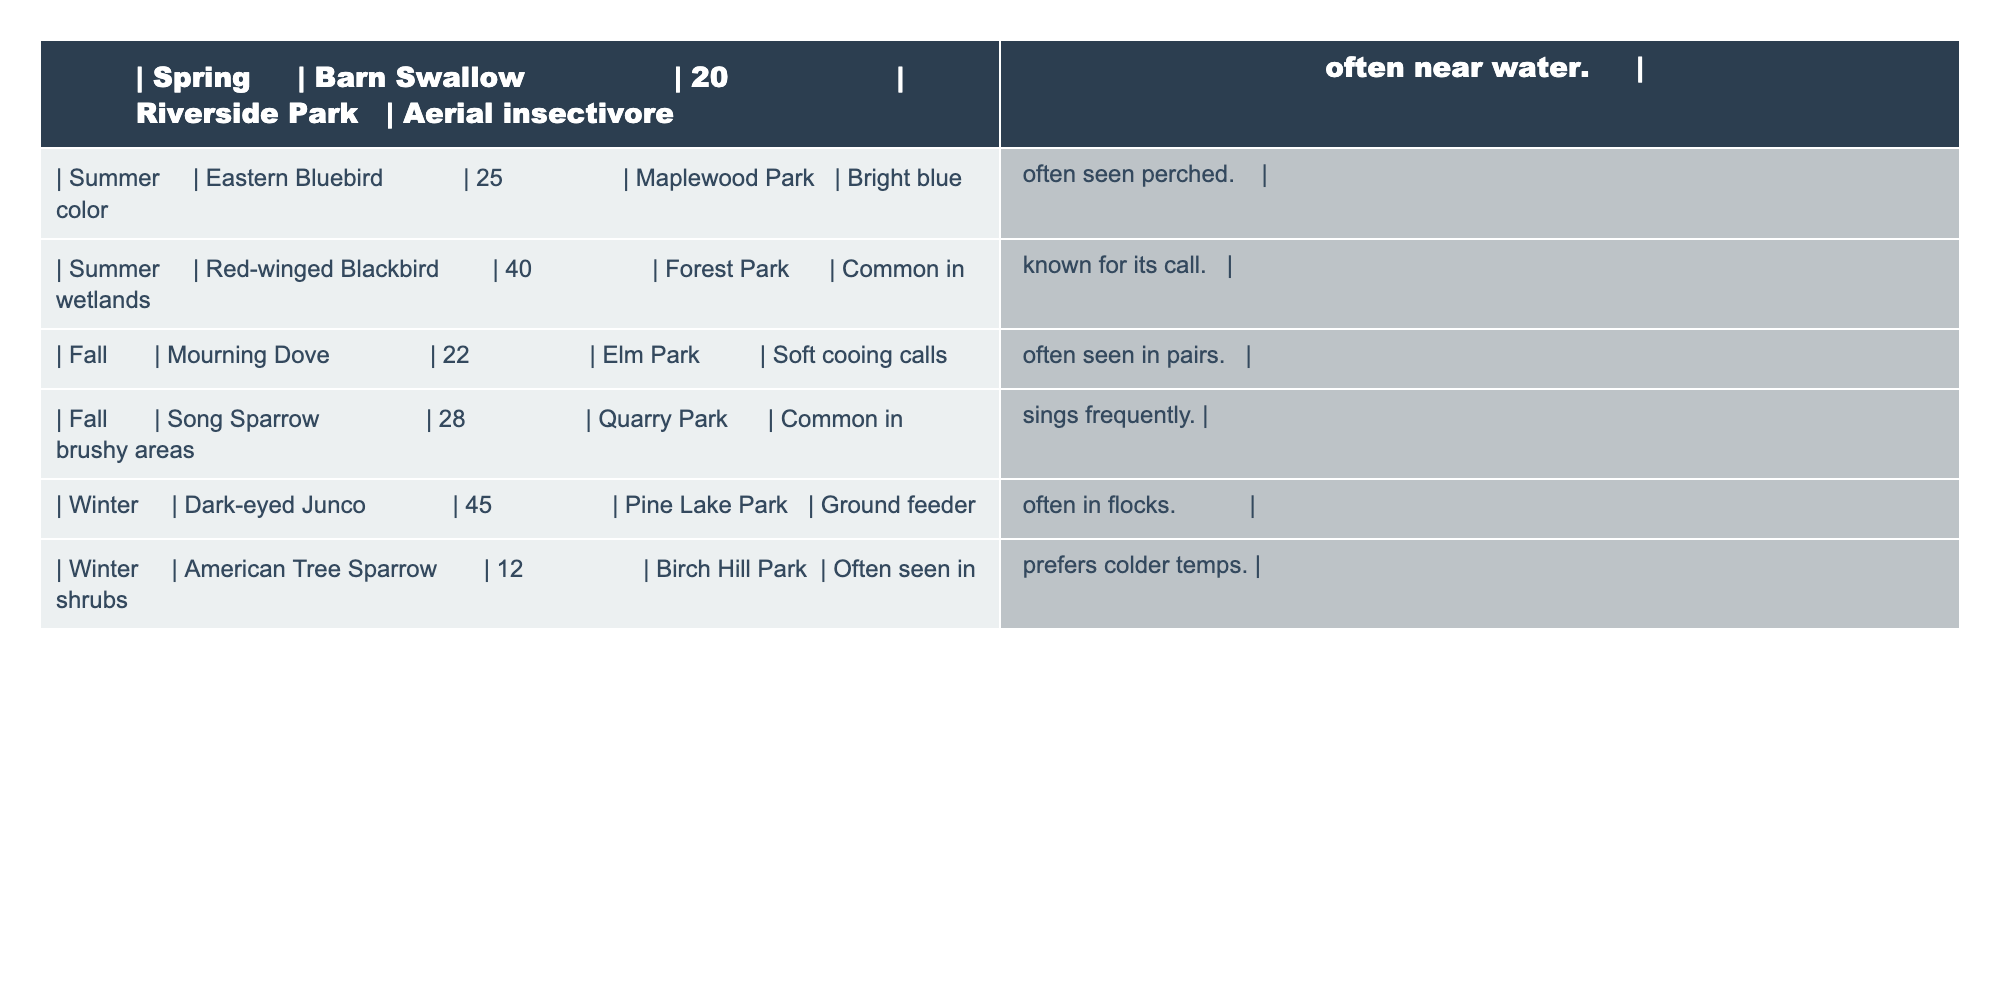What bird species was observed the most during the fall? The table shows a Mourning Dove with a count of 22 and a Song Sparrow with a count of 28. The Song Sparrow has the higher count for the fall season.
Answer: Song Sparrow How many bird species were identified in total across all seasons? There are 7 distinct bird species listed in the table: Barn Swallow, Eastern Bluebird, Red-winged Blackbird, Mourning Dove, Song Sparrow, Dark-eyed Junco, and American Tree Sparrow. Hence, the total is 7.
Answer: 7 What is the average number of birds identified per season? To find the average, add the numbers: 20 (Spring) + 25 (Summer) + 40 (Summer) + 22 (Fall) + 28 (Fall) + 45 (Winter) + 12 (Winter) = 192. Then divide by 7 (number of entries), which yields 27.43, rounded to 27.
Answer: 27 Is the Dark-eyed Junco identified in the spring? The table indicates that the Dark-eyed Junco is listed under winter, and there is no entry for spring. Therefore, it is not identified in the spring.
Answer: No Which park has the highest number of birds reported, and what is that number? The highest single count in the table is 45 for the Dark-eyed Junco observed at Pine Lake Park.
Answer: Pine Lake Park, 45 What is the difference in the number of Red-winged Blackbirds and American Tree Sparrows observed? The Red-winged Blackbird count is 40 while the American Tree Sparrow count is 12. The difference can be calculated by subtracting 12 from 40, which is 28.
Answer: 28 In which season is the Eastern Bluebird observed, and what is its count? The Eastern Bluebird is listed under summer with a count of 25, indicating it is only identified during that season.
Answer: Summer, 25 How many species were observed across maplewood and forest parks? In total, there are 2 species; Eastern Bluebird in Maplewood Park and Red-winged Blackbird in Forest Park.
Answer: 2 